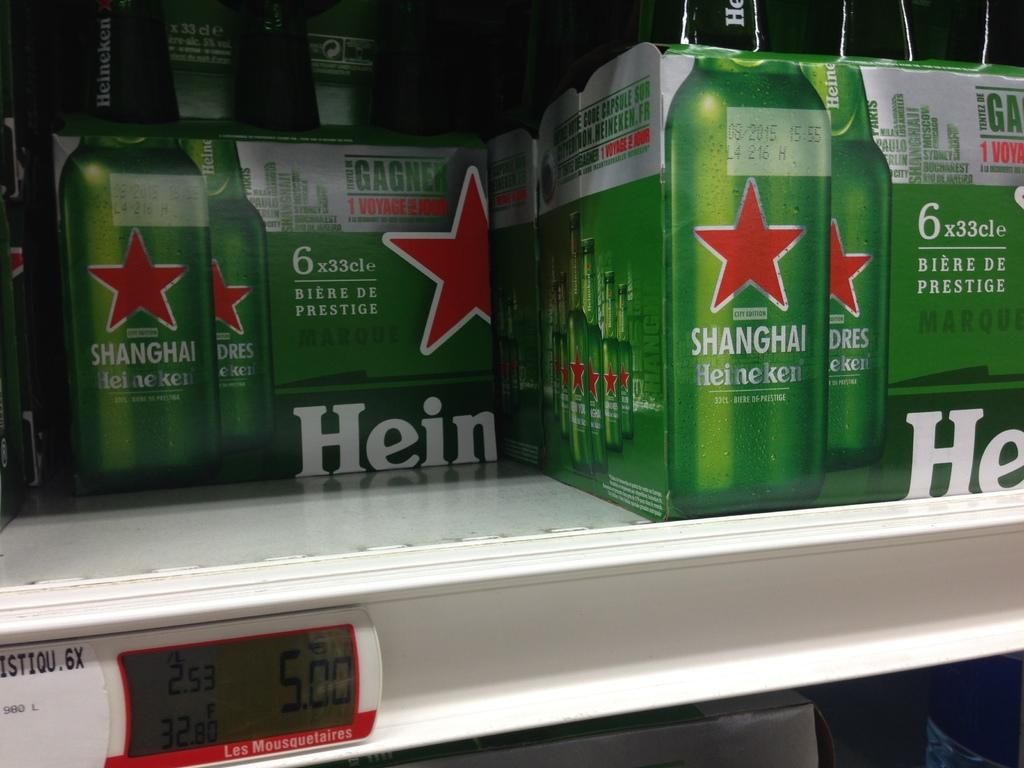<image>
Summarize the visual content of the image. packs of heneken beer bottles on a store shelf 